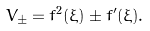<formula> <loc_0><loc_0><loc_500><loc_500>V _ { \pm } = f ^ { 2 } ( \xi ) \pm f ^ { \prime } ( \xi ) .</formula> 